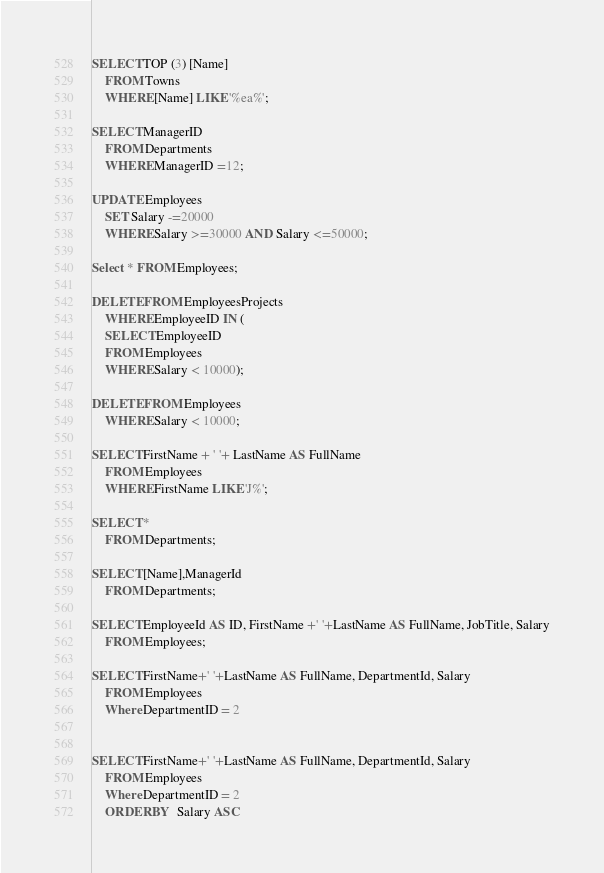Convert code to text. <code><loc_0><loc_0><loc_500><loc_500><_SQL_>SELECT TOP (3) [Name]
	FROM Towns 
	WHERE [Name] LIKE '%ea%';

SELECT ManagerID
	FROM Departments
	WHERE ManagerID =12;

UPDATE Employees
	SET Salary -=20000
	WHERE Salary >=30000 AND Salary <=50000;

Select * FROM Employees;

DELETE FROM EmployeesProjects
	WHERE EmployeeID IN (
	SELECT EmployeeID
	FROM Employees
	WHERE Salary < 10000);

DELETE FROM Employees	
	WHERE Salary < 10000;

SELECT FirstName + ' '+ LastName AS FullName
	FROM Employees
	WHERE FirstName LIKE 'J%';

SELECT * 
	FROM Departments;

SELECT [Name],ManagerId
	FROM Departments;

SELECT EmployeeId AS ID, FirstName +' '+LastName AS FullName, JobTitle, Salary
	FROM Employees;

SELECT FirstName+' '+LastName AS FullName, DepartmentId, Salary
	FROM Employees
	Where DepartmentID = 2


SELECT FirstName+' '+LastName AS FullName, DepartmentId, Salary
	FROM Employees
	Where DepartmentID = 2
	ORDER BY  Salary ASC
</code> 